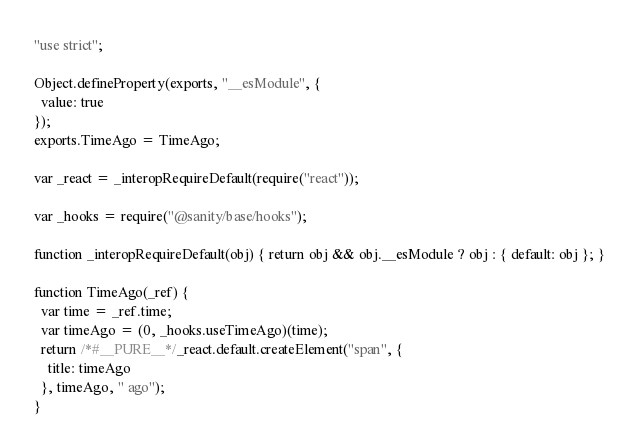<code> <loc_0><loc_0><loc_500><loc_500><_JavaScript_>"use strict";

Object.defineProperty(exports, "__esModule", {
  value: true
});
exports.TimeAgo = TimeAgo;

var _react = _interopRequireDefault(require("react"));

var _hooks = require("@sanity/base/hooks");

function _interopRequireDefault(obj) { return obj && obj.__esModule ? obj : { default: obj }; }

function TimeAgo(_ref) {
  var time = _ref.time;
  var timeAgo = (0, _hooks.useTimeAgo)(time);
  return /*#__PURE__*/_react.default.createElement("span", {
    title: timeAgo
  }, timeAgo, " ago");
}</code> 